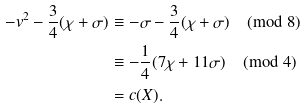<formula> <loc_0><loc_0><loc_500><loc_500>- v ^ { 2 } - \frac { 3 } { 4 } ( \chi + \sigma ) & \equiv - \sigma - \frac { 3 } { 4 } ( \chi + \sigma ) \pmod { 8 } \\ & \equiv - \frac { 1 } { 4 } ( 7 \chi + 1 1 \sigma ) \pmod { 4 } \\ & = c ( X ) .</formula> 